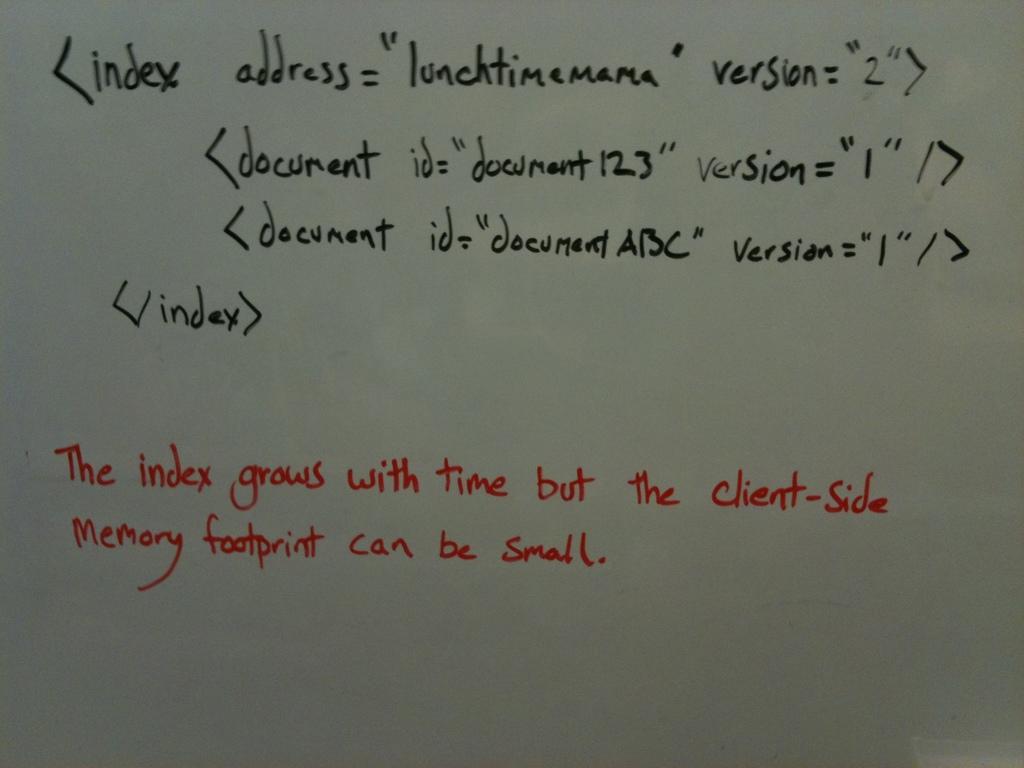What is the first word in black?
Provide a succinct answer. Index. 